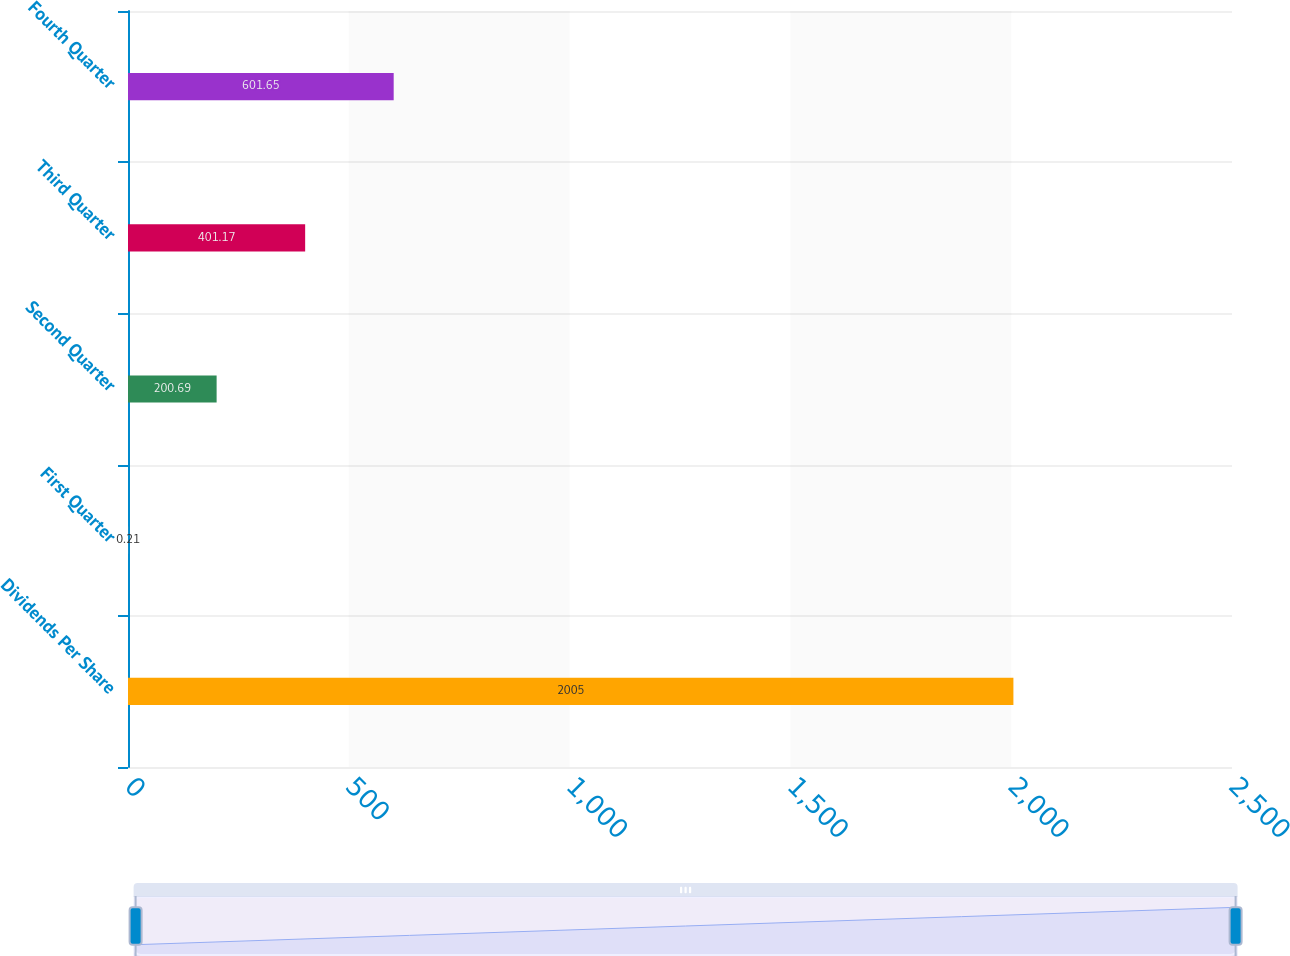Convert chart to OTSL. <chart><loc_0><loc_0><loc_500><loc_500><bar_chart><fcel>Dividends Per Share<fcel>First Quarter<fcel>Second Quarter<fcel>Third Quarter<fcel>Fourth Quarter<nl><fcel>2005<fcel>0.21<fcel>200.69<fcel>401.17<fcel>601.65<nl></chart> 